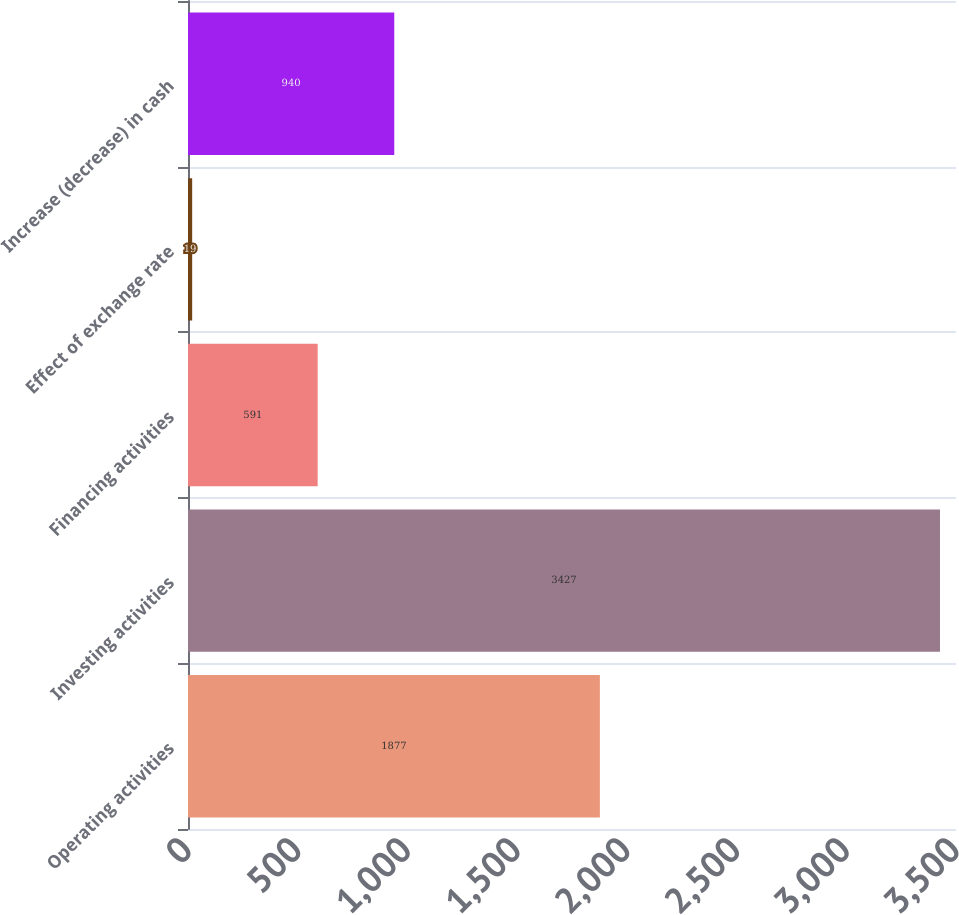Convert chart to OTSL. <chart><loc_0><loc_0><loc_500><loc_500><bar_chart><fcel>Operating activities<fcel>Investing activities<fcel>Financing activities<fcel>Effect of exchange rate<fcel>Increase (decrease) in cash<nl><fcel>1877<fcel>3427<fcel>591<fcel>19<fcel>940<nl></chart> 